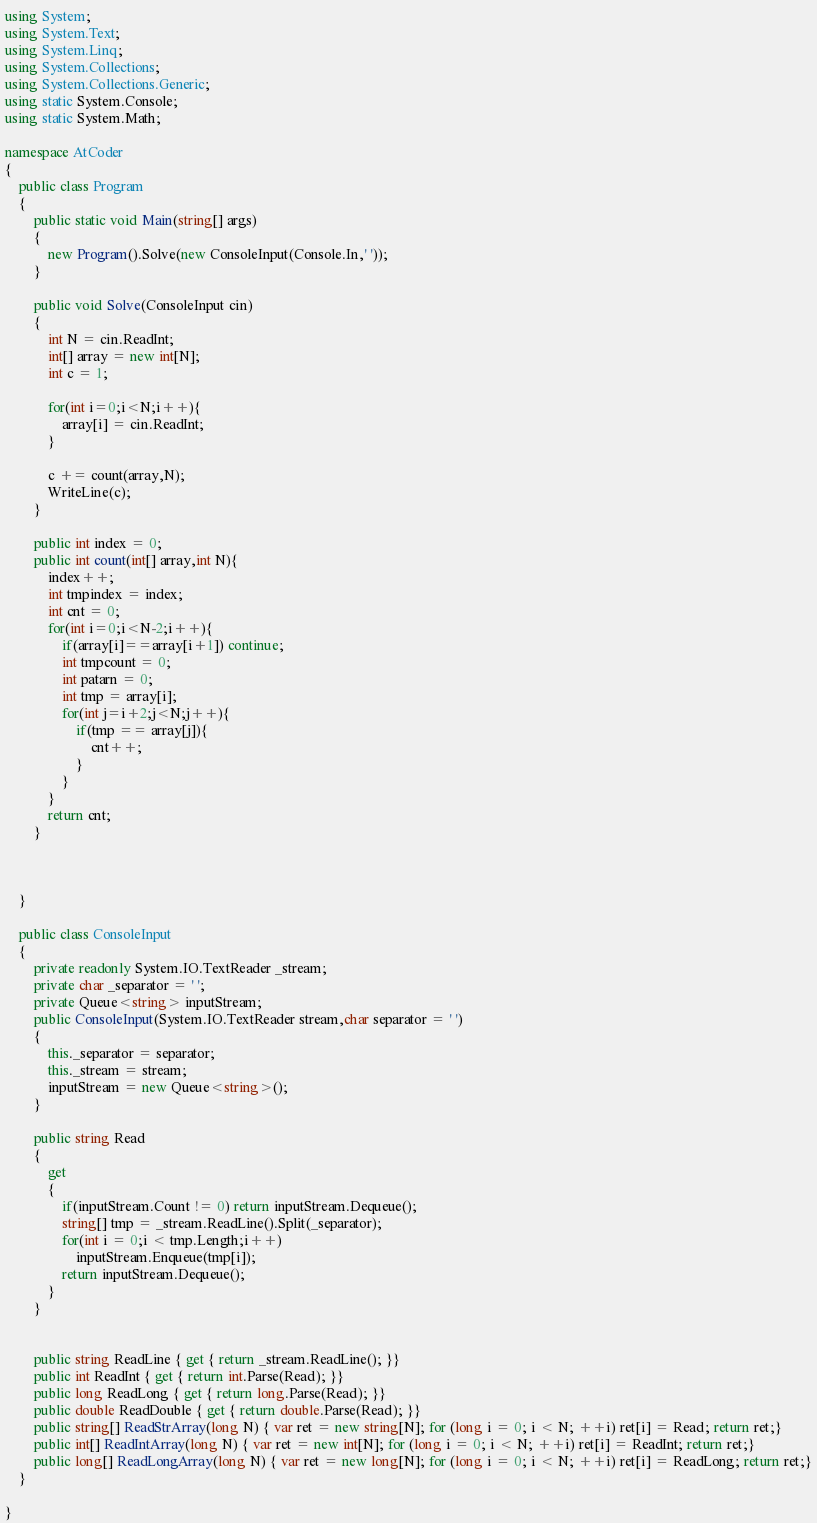Convert code to text. <code><loc_0><loc_0><loc_500><loc_500><_C#_>using System;
using System.Text;
using System.Linq;
using System.Collections;
using System.Collections.Generic;
using static System.Console;
using static System.Math;

namespace AtCoder
{
    public class Program
    {
        public static void Main(string[] args)
        {
            new Program().Solve(new ConsoleInput(Console.In,' '));
        }

        public void Solve(ConsoleInput cin)
        {
            int N = cin.ReadInt;
            int[] array = new int[N];
            int c = 1;

            for(int i=0;i<N;i++){
                array[i] = cin.ReadInt;
            }
          
          	c += count(array,N);
          	WriteLine(c);
        }

        public int index = 0;
        public int count(int[] array,int N){
            index++;
            int tmpindex = index;
            int cnt = 0;
            for(int i=0;i<N-2;i++){
                if(array[i]==array[i+1]) continue;
                int tmpcount = 0;
                int patarn = 0;
                int tmp = array[i];
                for(int j=i+2;j<N;j++){                    
                    if(tmp == array[j]){
                        cnt++;
                    }
                }
            }
            return cnt;
        }



    }

    public class ConsoleInput
    {
        private readonly System.IO.TextReader _stream;
        private char _separator = ' ';
        private Queue<string> inputStream;
        public ConsoleInput(System.IO.TextReader stream,char separator = ' ')
        {
            this._separator = separator;
            this._stream = stream;
            inputStream = new Queue<string>();
        }

        public string Read
        {
            get
            {
                if(inputStream.Count != 0) return inputStream.Dequeue();
                string[] tmp = _stream.ReadLine().Split(_separator);
                for(int i = 0;i < tmp.Length;i++)
                    inputStream.Enqueue(tmp[i]);
                return inputStream.Dequeue();
            }
        }

        
        public string ReadLine { get { return _stream.ReadLine(); }}
        public int ReadInt { get { return int.Parse(Read); }}
        public long ReadLong { get { return long.Parse(Read); }}
        public double ReadDouble { get { return double.Parse(Read); }}
        public string[] ReadStrArray(long N) { var ret = new string[N]; for (long i = 0; i < N; ++i) ret[i] = Read; return ret;}
        public int[] ReadIntArray(long N) { var ret = new int[N]; for (long i = 0; i < N; ++i) ret[i] = ReadInt; return ret;}
        public long[] ReadLongArray(long N) { var ret = new long[N]; for (long i = 0; i < N; ++i) ret[i] = ReadLong; return ret;}
    }

}</code> 